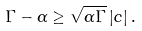<formula> <loc_0><loc_0><loc_500><loc_500>\Gamma - \alpha \geq \sqrt { \alpha \Gamma } \left | c \right | .</formula> 